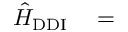<formula> <loc_0><loc_0><loc_500><loc_500>\begin{array} { r l } { \hat { H } _ { D D I } } & = } \end{array}</formula> 